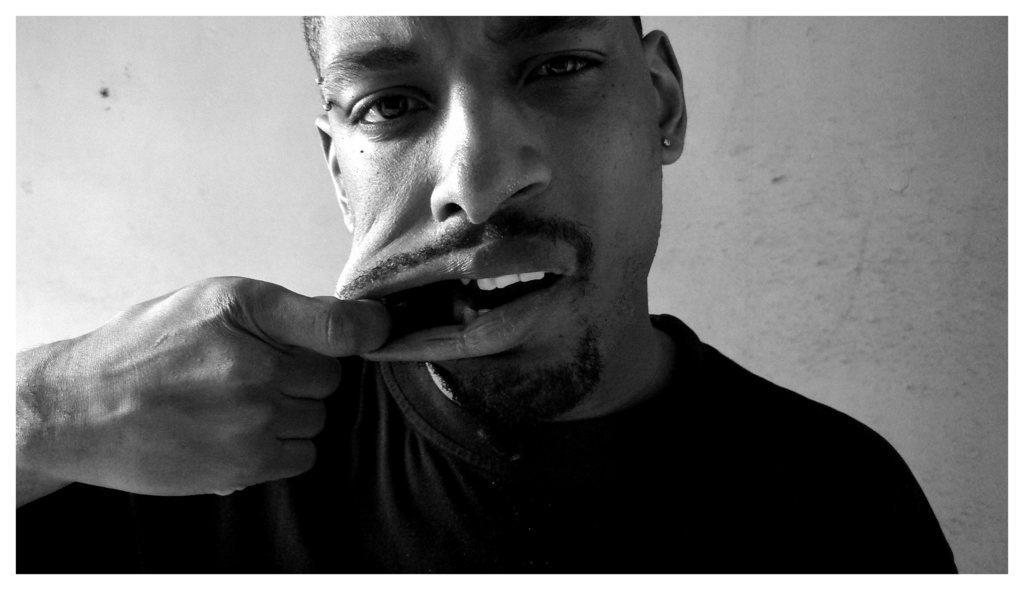Can you describe this image briefly? It is a black and white picture of a man opening his mouth with the help of his hand. In the background there is wall. 